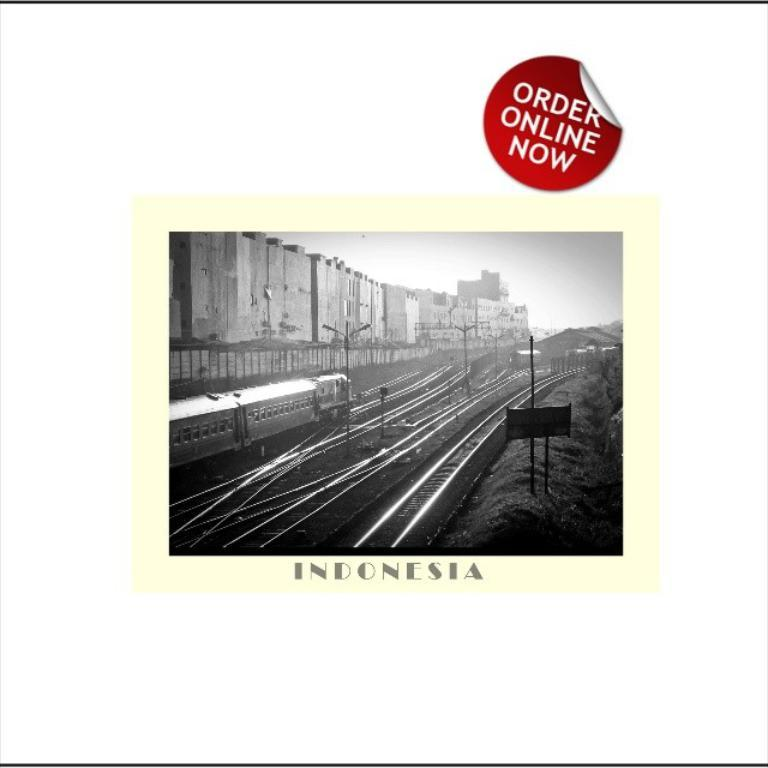<image>
Describe the image concisely. A train near several rail track crossings in Indonesia that can be Ordered Online. 